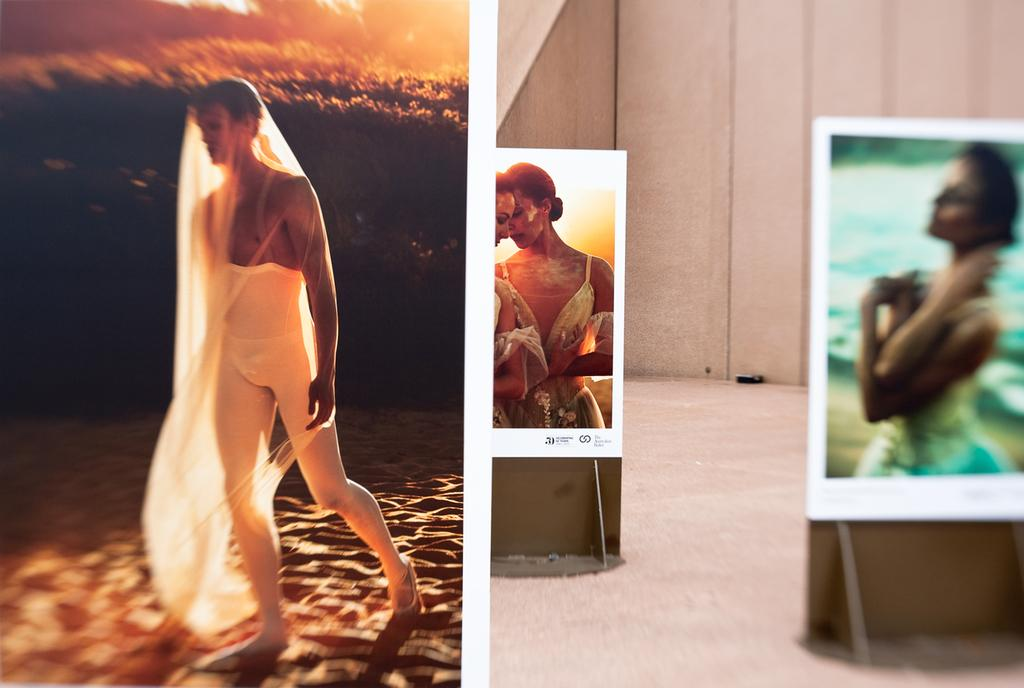What type of image is shown in the collage? The image is a photo collage. What can be seen on the left side of the collage? There is a person walking on the left side of the collage. What is depicted on the right side of the collage? There are two beautiful girls on the right side of the collage. What color are the dresses the girls are wearing? The girls are wearing white color dresses. How many sheep can be seen on the floor in the image? There are no sheep present in the image, and the floor is not visible in the photo collage. 